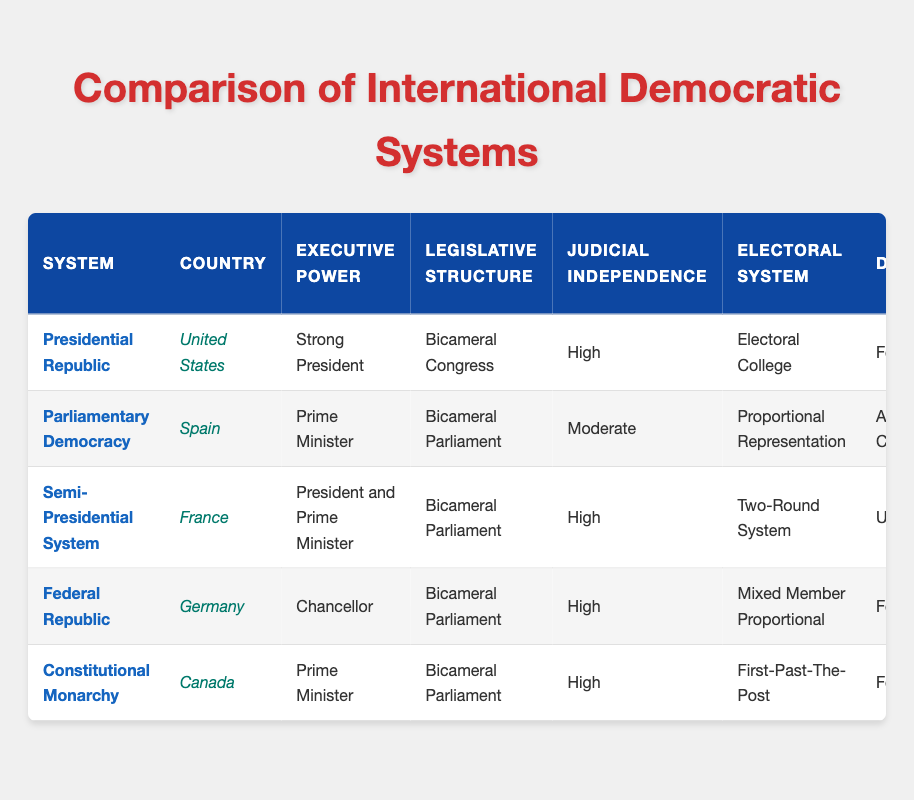What is the Corruption Perception Index for Germany? The Corruption Perception Index for Germany is directly listed in the table under "Corruption Perception Index," and it shows a value of 80.
Answer: 80 Which country has the highest Press Freedom Index? The Press Freedom Index values are listed in the table. Germany has a value of 85, which is the highest compared to the other countries.
Answer: Germany What is the primary role of the executive leader in a Presidential Republic? In the table, the "Executive Power" column for the United States, which operates under a Presidential Republic, indicates a "Strong President."
Answer: Strong President How many systems have a high level of Judicial Independence? The table lists Judicial Independence levels for each system. The systems with "High" or "Very Strong" levels are Presidential Republic (USA), Semi-Presidential System (France), Federal Republic (Germany), and Constitutional Monarchy (Canada), totaling 4 systems.
Answer: 4 Is the Civil Liberties Protection rating for Spain stronger than for France? Spain has a "Strong" rating for Civil Liberties Protection, while France also has a "Strong" rating according to the table, which means Spain's rating is not stronger than France's; they are equal.
Answer: No What is the median Economic Freedom Index of the listed countries? The Economic Freedom Index values are as follows: 74.8 (USA), 69.9 (Spain), 65.7 (France), 72.5 (Germany), and 77.9 (Canada). To find the median, we sort these values (65.7, 69.9, 72.5, 74.8, 77.9) and find the middle value, which is 72.5.
Answer: 72.5 How does the Corruption Perception Index for Canada compare to that of Spain? The Corruption Perception Index is 74 for Canada and 62 for Spain. Since 74 is greater than 62, Canada has a higher Corruption Perception Index than Spain.
Answer: Yes What is the total of the Economic Freedom Index values for the countries listed? The Economic Freedom Index values for the countries are: 74.8 (USA) + 69.9 (Spain) + 65.7 (France) + 72.5 (Germany) + 77.9 (Canada) = 360.8.
Answer: 360.8 Which system has the weakest Civil Liberties Protection according to the data? In the table, the Civil Liberties Protection values show "Moderate" for Spain and "Very Strong" for Germany and Canada. Since "Moderate" is the weakest rating among the listed systems, it indicates that Spain has the weakest Civil Liberties Protection.
Answer: Spain 